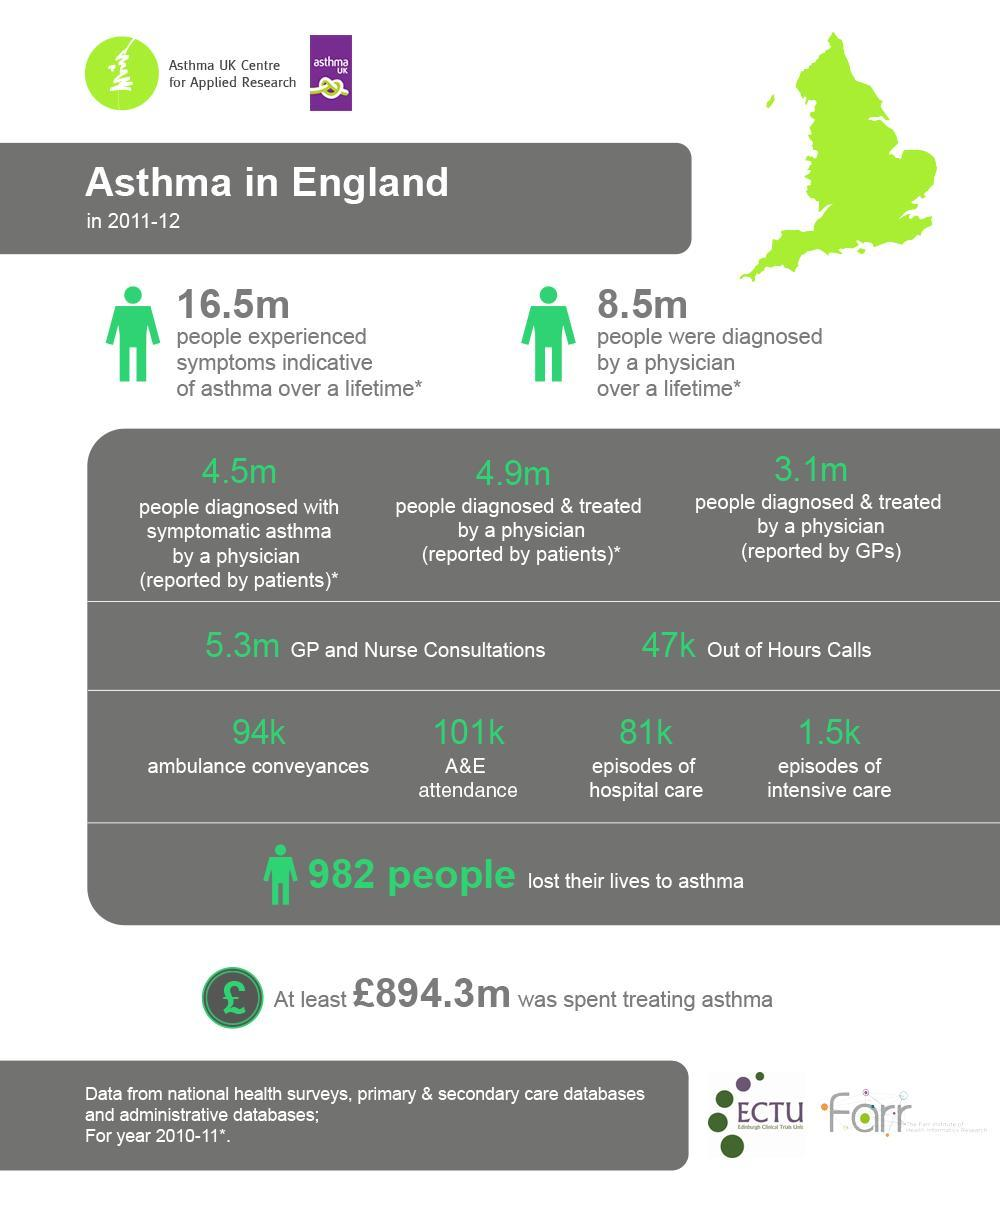What is the difference in the numbers reported by patients and GPs?
Answer the question with a short phrase. 1.8m 